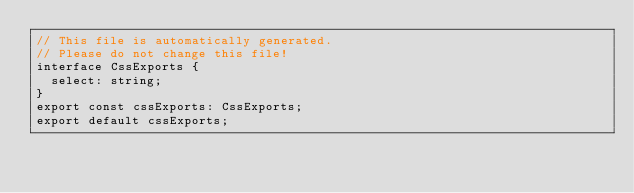<code> <loc_0><loc_0><loc_500><loc_500><_TypeScript_>// This file is automatically generated.
// Please do not change this file!
interface CssExports {
  select: string;
}
export const cssExports: CssExports;
export default cssExports;
</code> 